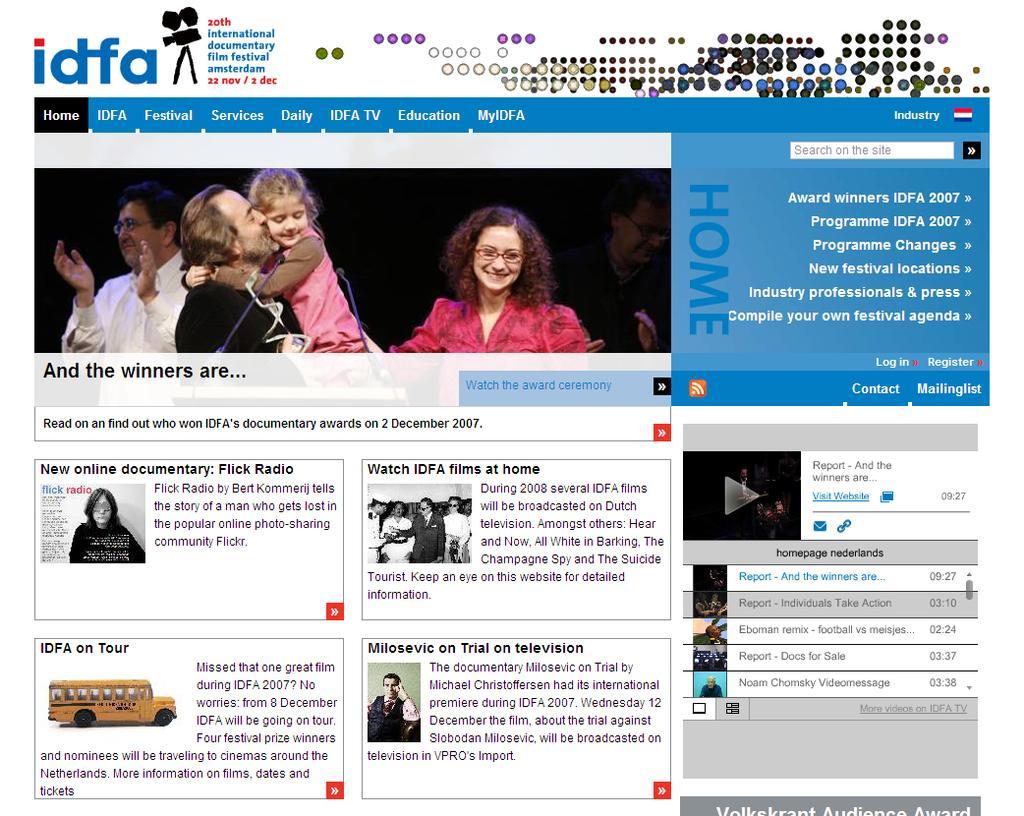Can you describe this image briefly? In this image there are few pictures of persons and a vehicle and there is some text. Top of image there is a person holding a girl in her arms. Beside him there is a woman wearing spectacles. Behind him there is a person wearing white shirt is clapping hand. Bottom of image there is a picture of a vehicle, beside there is some text. 